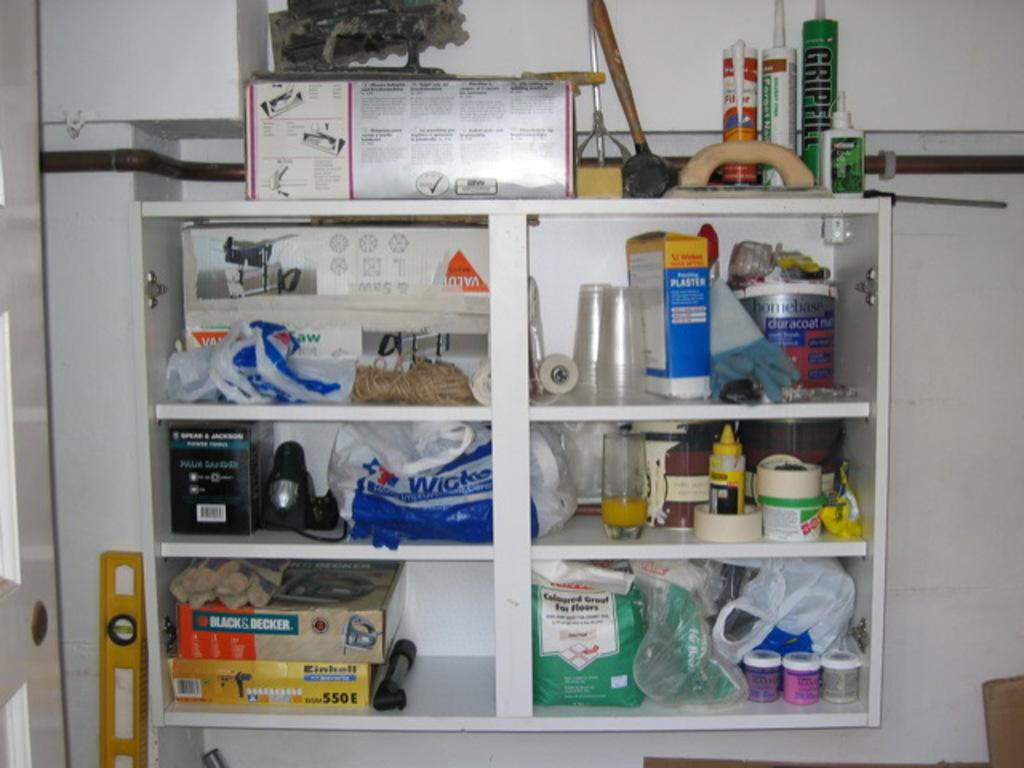<image>
Describe the image concisely. Some tools and home improvement tools line these shelves including a bottle of Gripfill. 